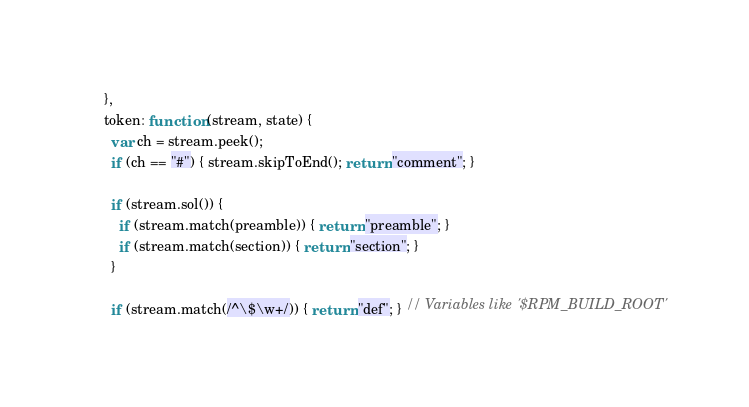Convert code to text. <code><loc_0><loc_0><loc_500><loc_500><_JavaScript_>    },
    token: function (stream, state) {
      var ch = stream.peek();
      if (ch == "#") { stream.skipToEnd(); return "comment"; }

      if (stream.sol()) {
        if (stream.match(preamble)) { return "preamble"; }
        if (stream.match(section)) { return "section"; }
      }

      if (stream.match(/^\$\w+/)) { return "def"; } // Variables like '$RPM_BUILD_ROOT'</code> 